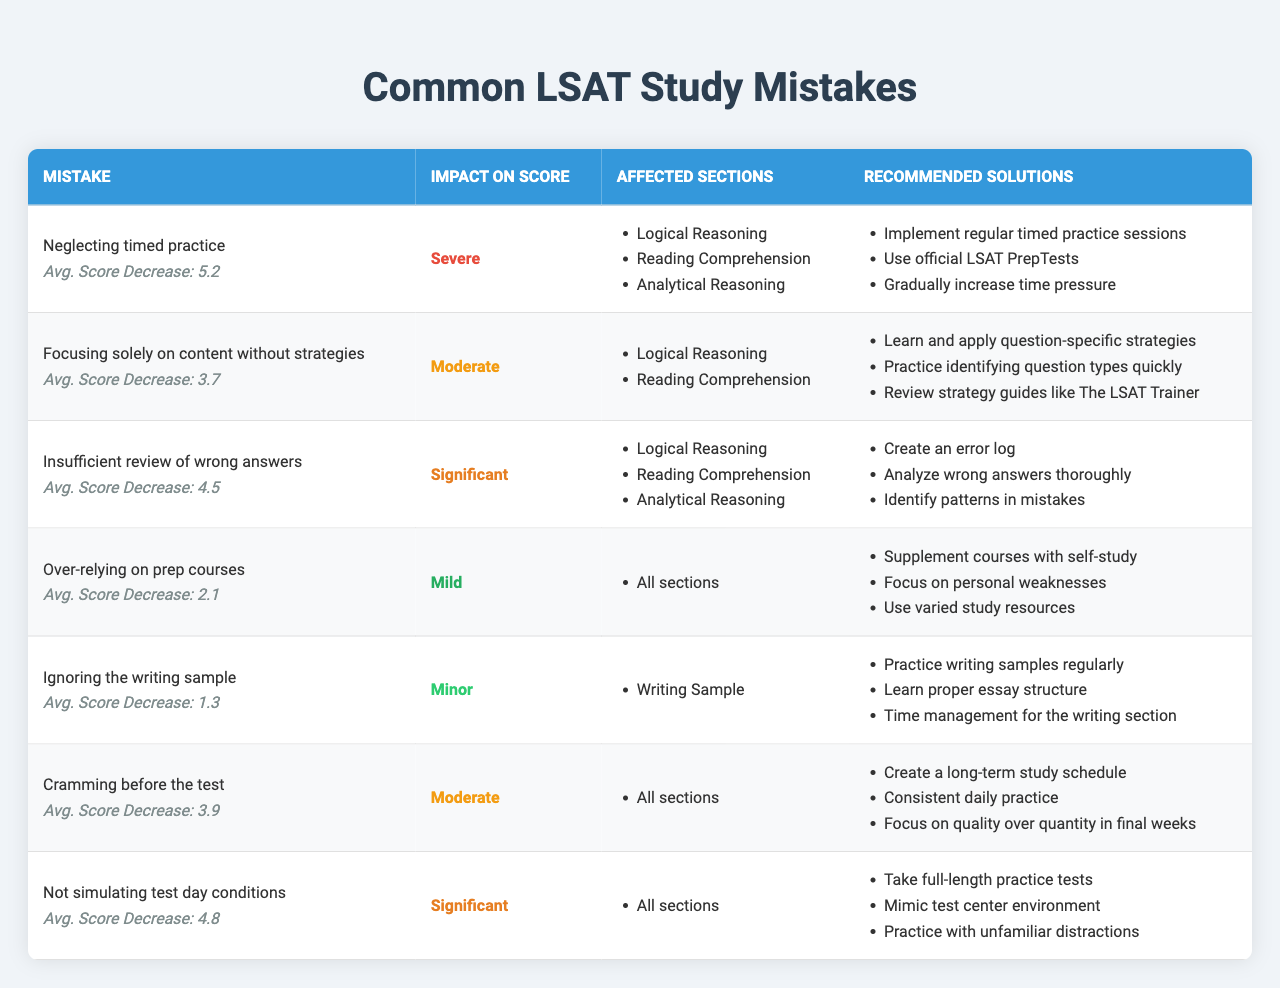What mistake results in the most severe impact on score? The table lists "Neglecting timed practice" as having a "Severe" impact on score, which is the highest severity level in the table.
Answer: Neglecting timed practice Which mistake has the highest average score decrease? Comparing the "Average Score Decrease" values for all mistakes, "Neglecting timed practice" has the highest average score decrease at 5.2.
Answer: 5.2 How many sections are affected by the mistake "Cramming before the test"? The table shows that "Cramming before the test" affects "All sections," which includes 3 main LSAT sections.
Answer: All sections What is the average score decrease for mistakes listed as having a "Significant" impact? The average score decrease for "Insufficient review of wrong answers" is 4.5, and for "Not simulating test day conditions" is 4.8; adding these gives 4.5 + 4.8 = 9.3. Since there are 2 mistakes, the average is 9.3 / 2 = 4.65.
Answer: 4.65 Is there a mistake associated with a minor impact and what is its average score decrease? Yes, "Ignoring the writing sample" is listed with a "Minor" impact and has an average score decrease of 1.3.
Answer: Yes, 1.3 Which mistake affects all sections but has a mild average score decrease? "Over-relying on prep courses" is the only mistake that affects all sections while having a mild average score decrease of 2.1.
Answer: Over-relying on prep courses How does the impact of the mistake "Not simulating test day conditions" compare to "Neglecting timed practice"? "Not simulating test day conditions" has a "Significant" impact while "Neglecting timed practice" has a "Severe" impact; thus, the latter indicates a higher level of concern.
Answer: Severe vs. Significant If a student implements all recommended solutions for "Insufficient review of wrong answers," how might their score change? Following the recommended solutions may address the issue of average score decrease for this mistake (4.5), potentially leading to score improvement, but the exact change cannot be determined from the table.
Answer: Improvement possible, exact score change unknown 